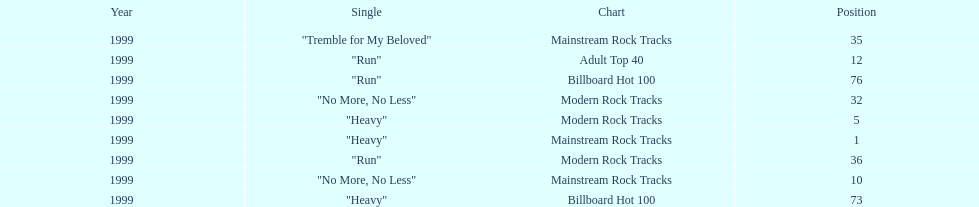How many different charts did "run" make? 3. 